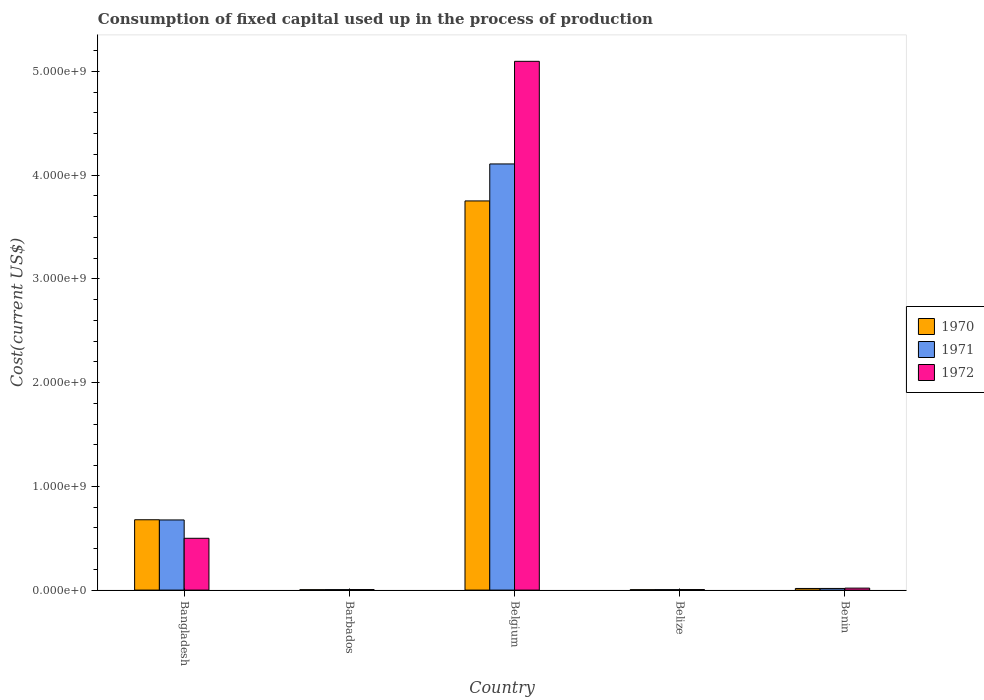How many groups of bars are there?
Ensure brevity in your answer.  5. Are the number of bars on each tick of the X-axis equal?
Offer a terse response. Yes. How many bars are there on the 4th tick from the left?
Make the answer very short. 3. What is the label of the 2nd group of bars from the left?
Give a very brief answer. Barbados. What is the amount consumed in the process of production in 1971 in Belize?
Keep it short and to the point. 4.54e+06. Across all countries, what is the maximum amount consumed in the process of production in 1971?
Provide a succinct answer. 4.11e+09. Across all countries, what is the minimum amount consumed in the process of production in 1971?
Offer a very short reply. 4.52e+06. In which country was the amount consumed in the process of production in 1972 minimum?
Make the answer very short. Belize. What is the total amount consumed in the process of production in 1972 in the graph?
Offer a terse response. 5.62e+09. What is the difference between the amount consumed in the process of production in 1972 in Belize and that in Benin?
Your answer should be very brief. -1.39e+07. What is the difference between the amount consumed in the process of production in 1970 in Belgium and the amount consumed in the process of production in 1971 in Benin?
Offer a terse response. 3.73e+09. What is the average amount consumed in the process of production in 1971 per country?
Offer a very short reply. 9.62e+08. What is the difference between the amount consumed in the process of production of/in 1972 and amount consumed in the process of production of/in 1971 in Barbados?
Offer a terse response. 9.05e+05. In how many countries, is the amount consumed in the process of production in 1970 greater than 3200000000 US$?
Keep it short and to the point. 1. What is the ratio of the amount consumed in the process of production in 1970 in Barbados to that in Belize?
Your answer should be very brief. 0.95. Is the difference between the amount consumed in the process of production in 1972 in Barbados and Benin greater than the difference between the amount consumed in the process of production in 1971 in Barbados and Benin?
Your answer should be very brief. No. What is the difference between the highest and the second highest amount consumed in the process of production in 1972?
Ensure brevity in your answer.  -4.80e+08. What is the difference between the highest and the lowest amount consumed in the process of production in 1970?
Provide a short and direct response. 3.75e+09. What does the 1st bar from the left in Barbados represents?
Give a very brief answer. 1970. What does the 3rd bar from the right in Belize represents?
Your answer should be compact. 1970. How many bars are there?
Offer a terse response. 15. Are all the bars in the graph horizontal?
Your response must be concise. No. Are the values on the major ticks of Y-axis written in scientific E-notation?
Your response must be concise. Yes. Does the graph contain any zero values?
Ensure brevity in your answer.  No. How are the legend labels stacked?
Provide a short and direct response. Vertical. What is the title of the graph?
Provide a succinct answer. Consumption of fixed capital used up in the process of production. Does "2006" appear as one of the legend labels in the graph?
Offer a very short reply. No. What is the label or title of the X-axis?
Keep it short and to the point. Country. What is the label or title of the Y-axis?
Your answer should be compact. Cost(current US$). What is the Cost(current US$) in 1970 in Bangladesh?
Offer a very short reply. 6.78e+08. What is the Cost(current US$) of 1971 in Bangladesh?
Provide a succinct answer. 6.76e+08. What is the Cost(current US$) of 1972 in Bangladesh?
Your answer should be compact. 4.99e+08. What is the Cost(current US$) in 1970 in Barbados?
Offer a very short reply. 3.84e+06. What is the Cost(current US$) of 1971 in Barbados?
Your answer should be compact. 4.52e+06. What is the Cost(current US$) in 1972 in Barbados?
Provide a succinct answer. 5.43e+06. What is the Cost(current US$) in 1970 in Belgium?
Provide a short and direct response. 3.75e+09. What is the Cost(current US$) in 1971 in Belgium?
Make the answer very short. 4.11e+09. What is the Cost(current US$) in 1972 in Belgium?
Offer a terse response. 5.10e+09. What is the Cost(current US$) of 1970 in Belize?
Provide a succinct answer. 4.05e+06. What is the Cost(current US$) of 1971 in Belize?
Your answer should be very brief. 4.54e+06. What is the Cost(current US$) in 1972 in Belize?
Your answer should be compact. 5.28e+06. What is the Cost(current US$) in 1970 in Benin?
Provide a succinct answer. 1.58e+07. What is the Cost(current US$) in 1971 in Benin?
Make the answer very short. 1.60e+07. What is the Cost(current US$) of 1972 in Benin?
Ensure brevity in your answer.  1.92e+07. Across all countries, what is the maximum Cost(current US$) in 1970?
Ensure brevity in your answer.  3.75e+09. Across all countries, what is the maximum Cost(current US$) of 1971?
Keep it short and to the point. 4.11e+09. Across all countries, what is the maximum Cost(current US$) of 1972?
Offer a terse response. 5.10e+09. Across all countries, what is the minimum Cost(current US$) of 1970?
Your answer should be very brief. 3.84e+06. Across all countries, what is the minimum Cost(current US$) of 1971?
Your answer should be compact. 4.52e+06. Across all countries, what is the minimum Cost(current US$) of 1972?
Your response must be concise. 5.28e+06. What is the total Cost(current US$) of 1970 in the graph?
Provide a short and direct response. 4.45e+09. What is the total Cost(current US$) of 1971 in the graph?
Offer a terse response. 4.81e+09. What is the total Cost(current US$) in 1972 in the graph?
Provide a succinct answer. 5.62e+09. What is the difference between the Cost(current US$) of 1970 in Bangladesh and that in Barbados?
Provide a succinct answer. 6.74e+08. What is the difference between the Cost(current US$) in 1971 in Bangladesh and that in Barbados?
Your answer should be very brief. 6.72e+08. What is the difference between the Cost(current US$) of 1972 in Bangladesh and that in Barbados?
Keep it short and to the point. 4.94e+08. What is the difference between the Cost(current US$) of 1970 in Bangladesh and that in Belgium?
Make the answer very short. -3.07e+09. What is the difference between the Cost(current US$) of 1971 in Bangladesh and that in Belgium?
Make the answer very short. -3.43e+09. What is the difference between the Cost(current US$) of 1972 in Bangladesh and that in Belgium?
Offer a terse response. -4.60e+09. What is the difference between the Cost(current US$) of 1970 in Bangladesh and that in Belize?
Ensure brevity in your answer.  6.74e+08. What is the difference between the Cost(current US$) of 1971 in Bangladesh and that in Belize?
Offer a terse response. 6.72e+08. What is the difference between the Cost(current US$) in 1972 in Bangladesh and that in Belize?
Provide a succinct answer. 4.94e+08. What is the difference between the Cost(current US$) in 1970 in Bangladesh and that in Benin?
Offer a terse response. 6.62e+08. What is the difference between the Cost(current US$) in 1971 in Bangladesh and that in Benin?
Keep it short and to the point. 6.60e+08. What is the difference between the Cost(current US$) of 1972 in Bangladesh and that in Benin?
Your response must be concise. 4.80e+08. What is the difference between the Cost(current US$) of 1970 in Barbados and that in Belgium?
Your answer should be compact. -3.75e+09. What is the difference between the Cost(current US$) in 1971 in Barbados and that in Belgium?
Offer a very short reply. -4.10e+09. What is the difference between the Cost(current US$) of 1972 in Barbados and that in Belgium?
Offer a terse response. -5.09e+09. What is the difference between the Cost(current US$) in 1970 in Barbados and that in Belize?
Ensure brevity in your answer.  -2.03e+05. What is the difference between the Cost(current US$) of 1971 in Barbados and that in Belize?
Provide a short and direct response. -1.64e+04. What is the difference between the Cost(current US$) of 1972 in Barbados and that in Belize?
Offer a terse response. 1.47e+05. What is the difference between the Cost(current US$) in 1970 in Barbados and that in Benin?
Keep it short and to the point. -1.19e+07. What is the difference between the Cost(current US$) of 1971 in Barbados and that in Benin?
Keep it short and to the point. -1.15e+07. What is the difference between the Cost(current US$) in 1972 in Barbados and that in Benin?
Offer a terse response. -1.37e+07. What is the difference between the Cost(current US$) of 1970 in Belgium and that in Belize?
Ensure brevity in your answer.  3.75e+09. What is the difference between the Cost(current US$) of 1971 in Belgium and that in Belize?
Give a very brief answer. 4.10e+09. What is the difference between the Cost(current US$) of 1972 in Belgium and that in Belize?
Provide a short and direct response. 5.09e+09. What is the difference between the Cost(current US$) of 1970 in Belgium and that in Benin?
Keep it short and to the point. 3.73e+09. What is the difference between the Cost(current US$) in 1971 in Belgium and that in Benin?
Your response must be concise. 4.09e+09. What is the difference between the Cost(current US$) of 1972 in Belgium and that in Benin?
Your response must be concise. 5.08e+09. What is the difference between the Cost(current US$) in 1970 in Belize and that in Benin?
Your answer should be very brief. -1.17e+07. What is the difference between the Cost(current US$) in 1971 in Belize and that in Benin?
Offer a very short reply. -1.15e+07. What is the difference between the Cost(current US$) of 1972 in Belize and that in Benin?
Your answer should be compact. -1.39e+07. What is the difference between the Cost(current US$) of 1970 in Bangladesh and the Cost(current US$) of 1971 in Barbados?
Your response must be concise. 6.73e+08. What is the difference between the Cost(current US$) in 1970 in Bangladesh and the Cost(current US$) in 1972 in Barbados?
Your answer should be very brief. 6.73e+08. What is the difference between the Cost(current US$) in 1971 in Bangladesh and the Cost(current US$) in 1972 in Barbados?
Provide a short and direct response. 6.71e+08. What is the difference between the Cost(current US$) of 1970 in Bangladesh and the Cost(current US$) of 1971 in Belgium?
Your answer should be very brief. -3.43e+09. What is the difference between the Cost(current US$) of 1970 in Bangladesh and the Cost(current US$) of 1972 in Belgium?
Give a very brief answer. -4.42e+09. What is the difference between the Cost(current US$) of 1971 in Bangladesh and the Cost(current US$) of 1972 in Belgium?
Give a very brief answer. -4.42e+09. What is the difference between the Cost(current US$) in 1970 in Bangladesh and the Cost(current US$) in 1971 in Belize?
Your response must be concise. 6.73e+08. What is the difference between the Cost(current US$) in 1970 in Bangladesh and the Cost(current US$) in 1972 in Belize?
Make the answer very short. 6.73e+08. What is the difference between the Cost(current US$) in 1971 in Bangladesh and the Cost(current US$) in 1972 in Belize?
Keep it short and to the point. 6.71e+08. What is the difference between the Cost(current US$) of 1970 in Bangladesh and the Cost(current US$) of 1971 in Benin?
Your answer should be compact. 6.62e+08. What is the difference between the Cost(current US$) of 1970 in Bangladesh and the Cost(current US$) of 1972 in Benin?
Keep it short and to the point. 6.59e+08. What is the difference between the Cost(current US$) of 1971 in Bangladesh and the Cost(current US$) of 1972 in Benin?
Your response must be concise. 6.57e+08. What is the difference between the Cost(current US$) in 1970 in Barbados and the Cost(current US$) in 1971 in Belgium?
Provide a succinct answer. -4.10e+09. What is the difference between the Cost(current US$) of 1970 in Barbados and the Cost(current US$) of 1972 in Belgium?
Your answer should be compact. -5.09e+09. What is the difference between the Cost(current US$) in 1971 in Barbados and the Cost(current US$) in 1972 in Belgium?
Your response must be concise. -5.09e+09. What is the difference between the Cost(current US$) of 1970 in Barbados and the Cost(current US$) of 1971 in Belize?
Your answer should be very brief. -6.94e+05. What is the difference between the Cost(current US$) of 1970 in Barbados and the Cost(current US$) of 1972 in Belize?
Offer a very short reply. -1.44e+06. What is the difference between the Cost(current US$) in 1971 in Barbados and the Cost(current US$) in 1972 in Belize?
Your answer should be compact. -7.58e+05. What is the difference between the Cost(current US$) of 1970 in Barbados and the Cost(current US$) of 1971 in Benin?
Your answer should be very brief. -1.22e+07. What is the difference between the Cost(current US$) of 1970 in Barbados and the Cost(current US$) of 1972 in Benin?
Offer a very short reply. -1.53e+07. What is the difference between the Cost(current US$) of 1971 in Barbados and the Cost(current US$) of 1972 in Benin?
Provide a short and direct response. -1.46e+07. What is the difference between the Cost(current US$) of 1970 in Belgium and the Cost(current US$) of 1971 in Belize?
Give a very brief answer. 3.75e+09. What is the difference between the Cost(current US$) in 1970 in Belgium and the Cost(current US$) in 1972 in Belize?
Give a very brief answer. 3.75e+09. What is the difference between the Cost(current US$) in 1971 in Belgium and the Cost(current US$) in 1972 in Belize?
Your answer should be very brief. 4.10e+09. What is the difference between the Cost(current US$) of 1970 in Belgium and the Cost(current US$) of 1971 in Benin?
Your answer should be compact. 3.73e+09. What is the difference between the Cost(current US$) in 1970 in Belgium and the Cost(current US$) in 1972 in Benin?
Provide a short and direct response. 3.73e+09. What is the difference between the Cost(current US$) in 1971 in Belgium and the Cost(current US$) in 1972 in Benin?
Make the answer very short. 4.09e+09. What is the difference between the Cost(current US$) in 1970 in Belize and the Cost(current US$) in 1971 in Benin?
Give a very brief answer. -1.20e+07. What is the difference between the Cost(current US$) in 1970 in Belize and the Cost(current US$) in 1972 in Benin?
Offer a terse response. -1.51e+07. What is the difference between the Cost(current US$) in 1971 in Belize and the Cost(current US$) in 1972 in Benin?
Provide a succinct answer. -1.46e+07. What is the average Cost(current US$) in 1970 per country?
Make the answer very short. 8.90e+08. What is the average Cost(current US$) of 1971 per country?
Ensure brevity in your answer.  9.62e+08. What is the average Cost(current US$) of 1972 per country?
Offer a very short reply. 1.12e+09. What is the difference between the Cost(current US$) of 1970 and Cost(current US$) of 1971 in Bangladesh?
Keep it short and to the point. 1.86e+06. What is the difference between the Cost(current US$) of 1970 and Cost(current US$) of 1972 in Bangladesh?
Your answer should be compact. 1.79e+08. What is the difference between the Cost(current US$) of 1971 and Cost(current US$) of 1972 in Bangladesh?
Offer a very short reply. 1.77e+08. What is the difference between the Cost(current US$) of 1970 and Cost(current US$) of 1971 in Barbados?
Your answer should be compact. -6.77e+05. What is the difference between the Cost(current US$) of 1970 and Cost(current US$) of 1972 in Barbados?
Give a very brief answer. -1.58e+06. What is the difference between the Cost(current US$) in 1971 and Cost(current US$) in 1972 in Barbados?
Your answer should be very brief. -9.05e+05. What is the difference between the Cost(current US$) of 1970 and Cost(current US$) of 1971 in Belgium?
Offer a terse response. -3.56e+08. What is the difference between the Cost(current US$) of 1970 and Cost(current US$) of 1972 in Belgium?
Your answer should be very brief. -1.35e+09. What is the difference between the Cost(current US$) in 1971 and Cost(current US$) in 1972 in Belgium?
Offer a very short reply. -9.89e+08. What is the difference between the Cost(current US$) in 1970 and Cost(current US$) in 1971 in Belize?
Your answer should be compact. -4.90e+05. What is the difference between the Cost(current US$) in 1970 and Cost(current US$) in 1972 in Belize?
Your response must be concise. -1.23e+06. What is the difference between the Cost(current US$) in 1971 and Cost(current US$) in 1972 in Belize?
Offer a very short reply. -7.42e+05. What is the difference between the Cost(current US$) of 1970 and Cost(current US$) of 1971 in Benin?
Keep it short and to the point. -2.44e+05. What is the difference between the Cost(current US$) in 1970 and Cost(current US$) in 1972 in Benin?
Provide a succinct answer. -3.40e+06. What is the difference between the Cost(current US$) in 1971 and Cost(current US$) in 1972 in Benin?
Ensure brevity in your answer.  -3.16e+06. What is the ratio of the Cost(current US$) of 1970 in Bangladesh to that in Barbados?
Keep it short and to the point. 176.39. What is the ratio of the Cost(current US$) in 1971 in Bangladesh to that in Barbados?
Offer a very short reply. 149.55. What is the ratio of the Cost(current US$) of 1972 in Bangladesh to that in Barbados?
Your answer should be compact. 92.02. What is the ratio of the Cost(current US$) in 1970 in Bangladesh to that in Belgium?
Your answer should be compact. 0.18. What is the ratio of the Cost(current US$) of 1971 in Bangladesh to that in Belgium?
Make the answer very short. 0.16. What is the ratio of the Cost(current US$) of 1972 in Bangladesh to that in Belgium?
Make the answer very short. 0.1. What is the ratio of the Cost(current US$) of 1970 in Bangladesh to that in Belize?
Ensure brevity in your answer.  167.52. What is the ratio of the Cost(current US$) in 1971 in Bangladesh to that in Belize?
Offer a very short reply. 149.01. What is the ratio of the Cost(current US$) in 1972 in Bangladesh to that in Belize?
Make the answer very short. 94.58. What is the ratio of the Cost(current US$) in 1970 in Bangladesh to that in Benin?
Your answer should be compact. 43.01. What is the ratio of the Cost(current US$) in 1971 in Bangladesh to that in Benin?
Keep it short and to the point. 42.24. What is the ratio of the Cost(current US$) in 1972 in Bangladesh to that in Benin?
Offer a terse response. 26.05. What is the ratio of the Cost(current US$) in 1971 in Barbados to that in Belgium?
Ensure brevity in your answer.  0. What is the ratio of the Cost(current US$) of 1972 in Barbados to that in Belgium?
Offer a very short reply. 0. What is the ratio of the Cost(current US$) of 1970 in Barbados to that in Belize?
Give a very brief answer. 0.95. What is the ratio of the Cost(current US$) in 1972 in Barbados to that in Belize?
Make the answer very short. 1.03. What is the ratio of the Cost(current US$) of 1970 in Barbados to that in Benin?
Your response must be concise. 0.24. What is the ratio of the Cost(current US$) in 1971 in Barbados to that in Benin?
Your answer should be very brief. 0.28. What is the ratio of the Cost(current US$) of 1972 in Barbados to that in Benin?
Your answer should be compact. 0.28. What is the ratio of the Cost(current US$) in 1970 in Belgium to that in Belize?
Provide a short and direct response. 926.74. What is the ratio of the Cost(current US$) in 1971 in Belgium to that in Belize?
Your answer should be compact. 905.15. What is the ratio of the Cost(current US$) of 1972 in Belgium to that in Belize?
Your answer should be compact. 965.32. What is the ratio of the Cost(current US$) in 1970 in Belgium to that in Benin?
Ensure brevity in your answer.  237.92. What is the ratio of the Cost(current US$) in 1971 in Belgium to that in Benin?
Your response must be concise. 256.57. What is the ratio of the Cost(current US$) in 1972 in Belgium to that in Benin?
Offer a terse response. 265.9. What is the ratio of the Cost(current US$) in 1970 in Belize to that in Benin?
Provide a short and direct response. 0.26. What is the ratio of the Cost(current US$) of 1971 in Belize to that in Benin?
Ensure brevity in your answer.  0.28. What is the ratio of the Cost(current US$) in 1972 in Belize to that in Benin?
Keep it short and to the point. 0.28. What is the difference between the highest and the second highest Cost(current US$) in 1970?
Your response must be concise. 3.07e+09. What is the difference between the highest and the second highest Cost(current US$) in 1971?
Your response must be concise. 3.43e+09. What is the difference between the highest and the second highest Cost(current US$) in 1972?
Your answer should be compact. 4.60e+09. What is the difference between the highest and the lowest Cost(current US$) of 1970?
Make the answer very short. 3.75e+09. What is the difference between the highest and the lowest Cost(current US$) of 1971?
Your response must be concise. 4.10e+09. What is the difference between the highest and the lowest Cost(current US$) in 1972?
Provide a short and direct response. 5.09e+09. 